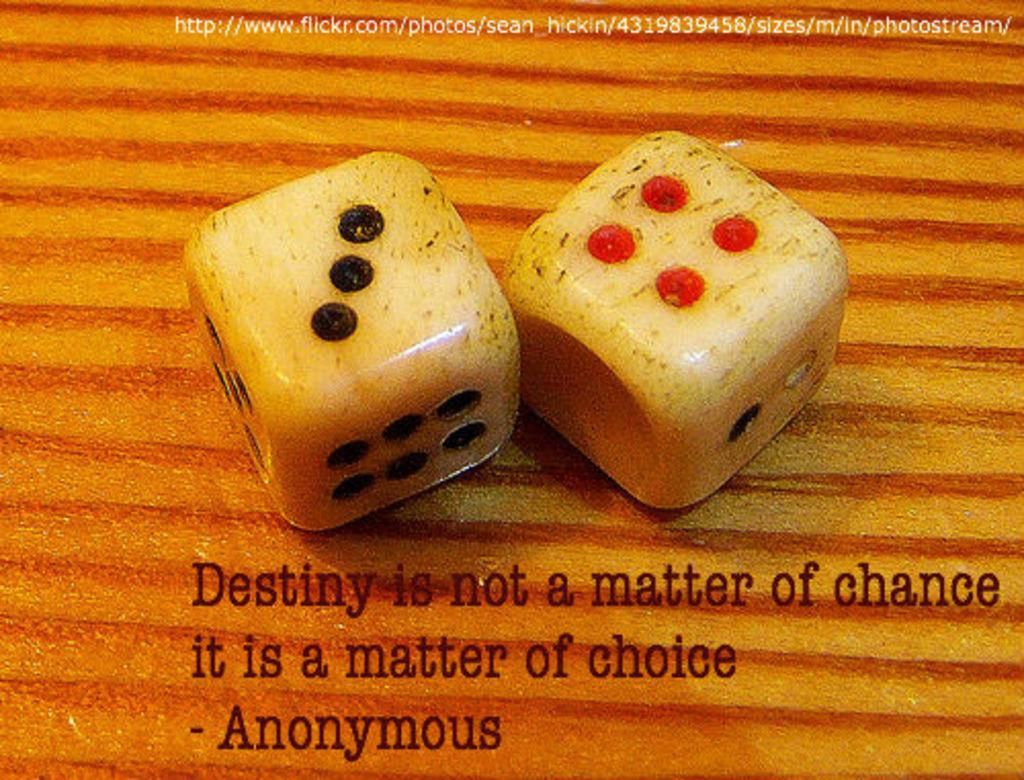How many coins are visible in the image? There are two dimes in the image. What type of text can be seen in the image? There is text written on the image. What is the middle of the neck looking like in the image? There is no reference to a neck or any middle part in the image, as it only contains two dimes and text. 